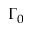Convert formula to latex. <formula><loc_0><loc_0><loc_500><loc_500>\Gamma _ { 0 }</formula> 